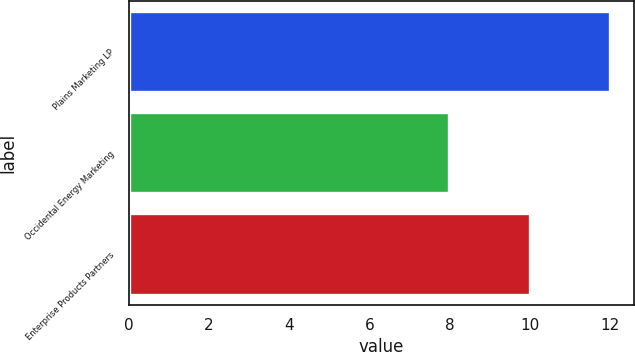Convert chart. <chart><loc_0><loc_0><loc_500><loc_500><bar_chart><fcel>Plains Marketing LP<fcel>Occidental Energy Marketing<fcel>Enterprise Products Partners<nl><fcel>12<fcel>8<fcel>10<nl></chart> 